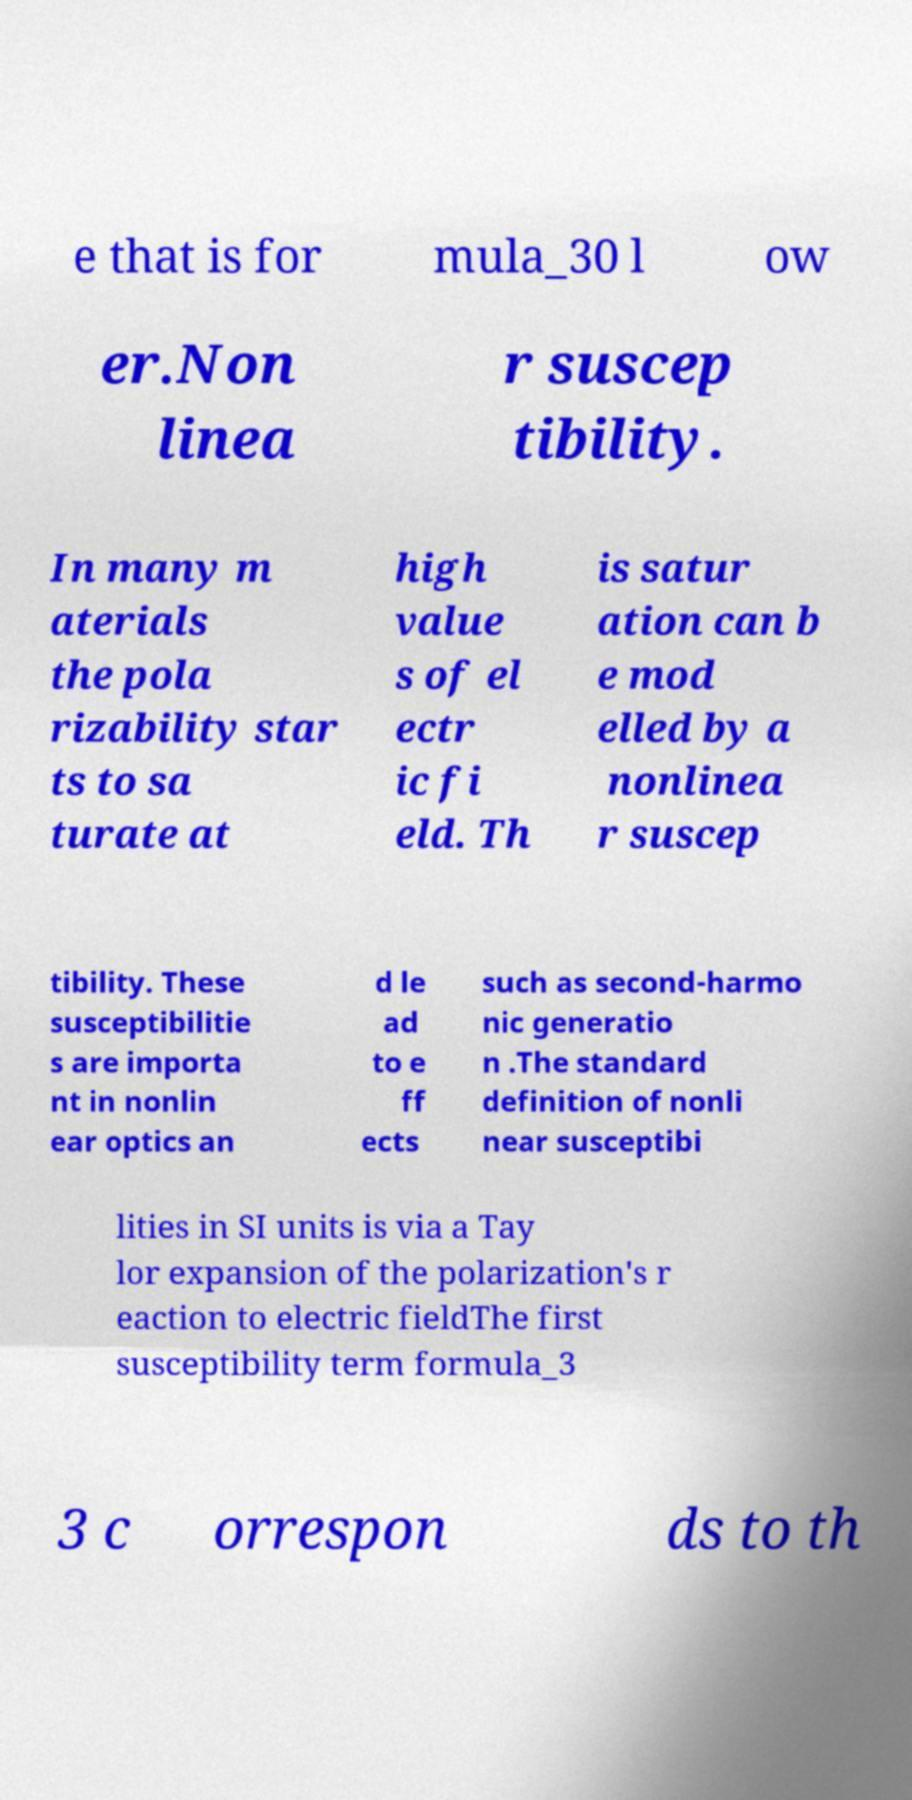Can you read and provide the text displayed in the image?This photo seems to have some interesting text. Can you extract and type it out for me? e that is for mula_30 l ow er.Non linea r suscep tibility. In many m aterials the pola rizability star ts to sa turate at high value s of el ectr ic fi eld. Th is satur ation can b e mod elled by a nonlinea r suscep tibility. These susceptibilitie s are importa nt in nonlin ear optics an d le ad to e ff ects such as second-harmo nic generatio n .The standard definition of nonli near susceptibi lities in SI units is via a Tay lor expansion of the polarization's r eaction to electric fieldThe first susceptibility term formula_3 3 c orrespon ds to th 